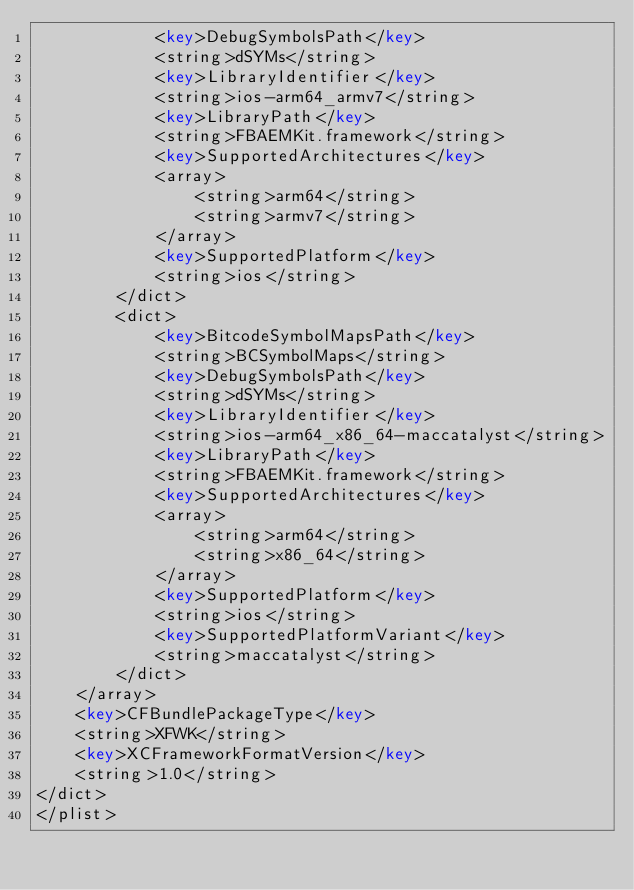<code> <loc_0><loc_0><loc_500><loc_500><_XML_>			<key>DebugSymbolsPath</key>
			<string>dSYMs</string>
			<key>LibraryIdentifier</key>
			<string>ios-arm64_armv7</string>
			<key>LibraryPath</key>
			<string>FBAEMKit.framework</string>
			<key>SupportedArchitectures</key>
			<array>
				<string>arm64</string>
				<string>armv7</string>
			</array>
			<key>SupportedPlatform</key>
			<string>ios</string>
		</dict>
		<dict>
			<key>BitcodeSymbolMapsPath</key>
			<string>BCSymbolMaps</string>
			<key>DebugSymbolsPath</key>
			<string>dSYMs</string>
			<key>LibraryIdentifier</key>
			<string>ios-arm64_x86_64-maccatalyst</string>
			<key>LibraryPath</key>
			<string>FBAEMKit.framework</string>
			<key>SupportedArchitectures</key>
			<array>
				<string>arm64</string>
				<string>x86_64</string>
			</array>
			<key>SupportedPlatform</key>
			<string>ios</string>
			<key>SupportedPlatformVariant</key>
			<string>maccatalyst</string>
		</dict>
	</array>
	<key>CFBundlePackageType</key>
	<string>XFWK</string>
	<key>XCFrameworkFormatVersion</key>
	<string>1.0</string>
</dict>
</plist>
</code> 